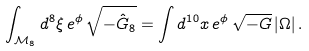<formula> <loc_0><loc_0><loc_500><loc_500>\int _ { \mathcal { M } _ { 8 } } d ^ { 8 } \xi \, e ^ { \phi } \, \sqrt { - \hat { G } _ { 8 } } = \int d ^ { 1 0 } x \, e ^ { \phi } \, \sqrt { - G } \, | \Omega | \, .</formula> 